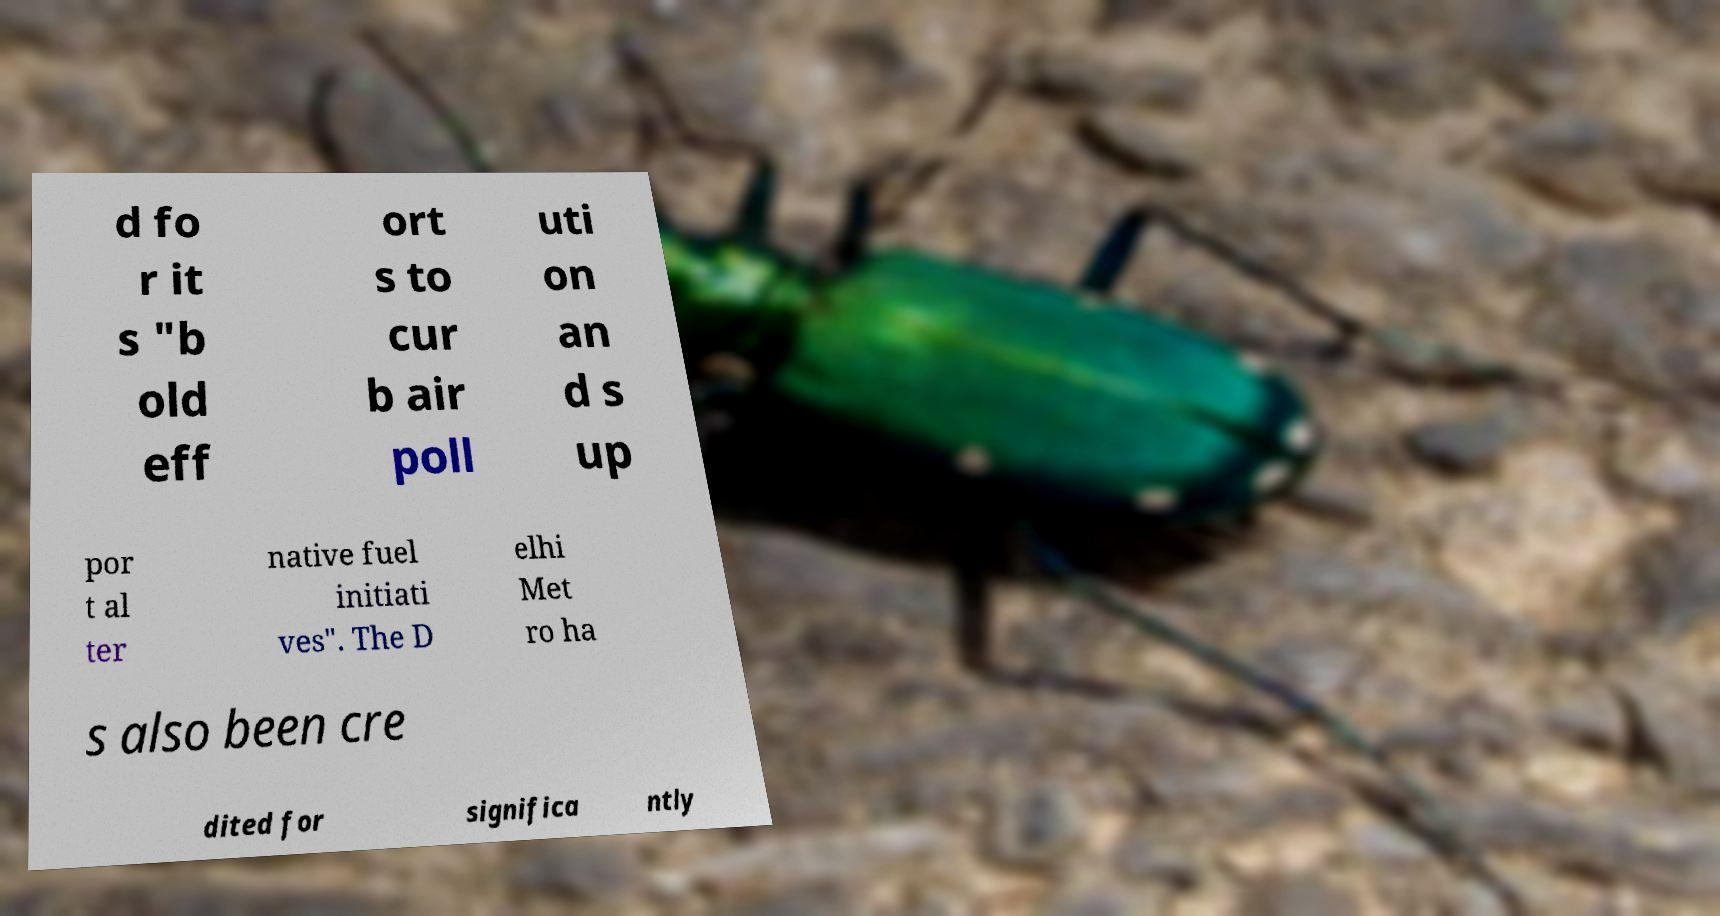I need the written content from this picture converted into text. Can you do that? d fo r it s "b old eff ort s to cur b air poll uti on an d s up por t al ter native fuel initiati ves". The D elhi Met ro ha s also been cre dited for significa ntly 